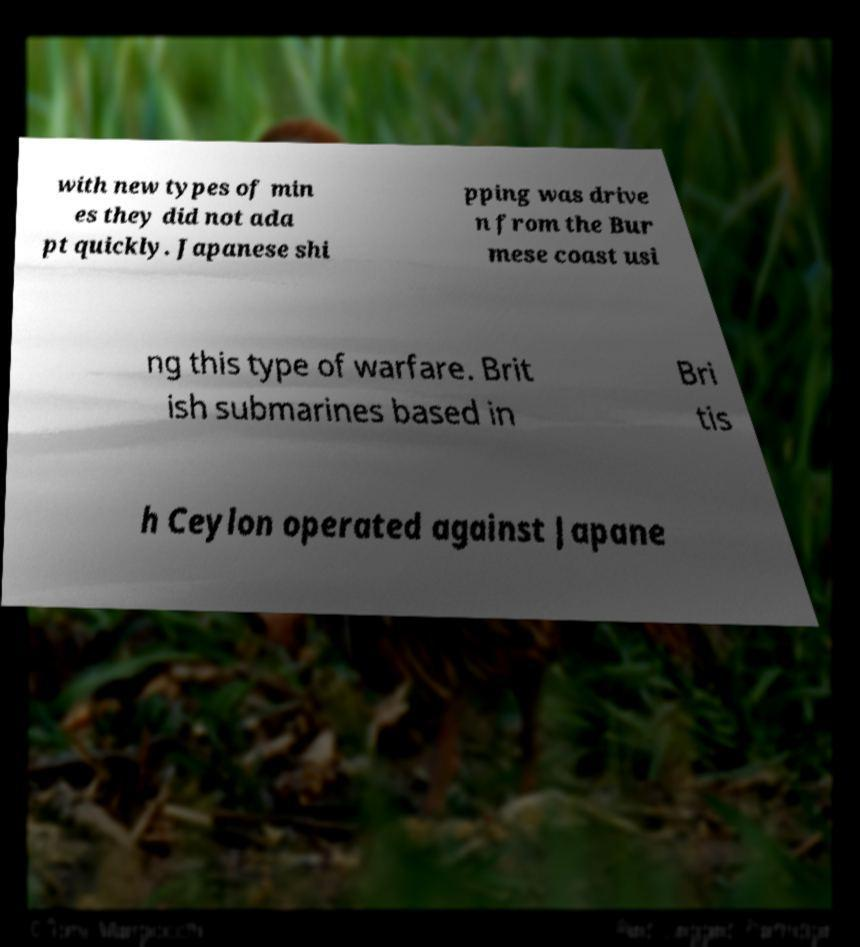Can you accurately transcribe the text from the provided image for me? with new types of min es they did not ada pt quickly. Japanese shi pping was drive n from the Bur mese coast usi ng this type of warfare. Brit ish submarines based in Bri tis h Ceylon operated against Japane 